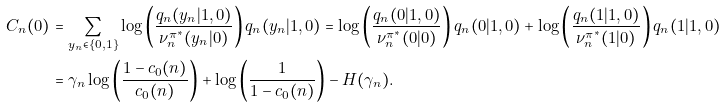<formula> <loc_0><loc_0><loc_500><loc_500>C _ { n } ( 0 ) & = \sum _ { y _ { n } \in \{ 0 , 1 \} } \log \left ( \frac { q _ { n } ( y _ { n } | 1 , 0 ) } { \nu ^ { \pi ^ { * } } _ { n } ( y _ { n } | 0 ) } \right ) q _ { n } ( y _ { n } | 1 , 0 ) = \log \left ( \frac { q _ { n } ( 0 | 1 , 0 ) } { \nu ^ { \pi ^ { * } } _ { n } ( 0 | 0 ) } \right ) q _ { n } ( 0 | 1 , 0 ) + \log \left ( \frac { q _ { n } ( 1 | 1 , 0 ) } { \nu ^ { \pi ^ { * } } _ { n } ( 1 | 0 ) } \right ) q _ { n } ( 1 | 1 , 0 ) \\ & = \gamma _ { n } \log \left ( \frac { 1 - c _ { 0 } ( n ) } { c _ { 0 } ( n ) } \right ) + \log \left ( \frac { 1 } { 1 - c _ { 0 } ( n ) } \right ) - H ( \gamma _ { n } ) .</formula> 